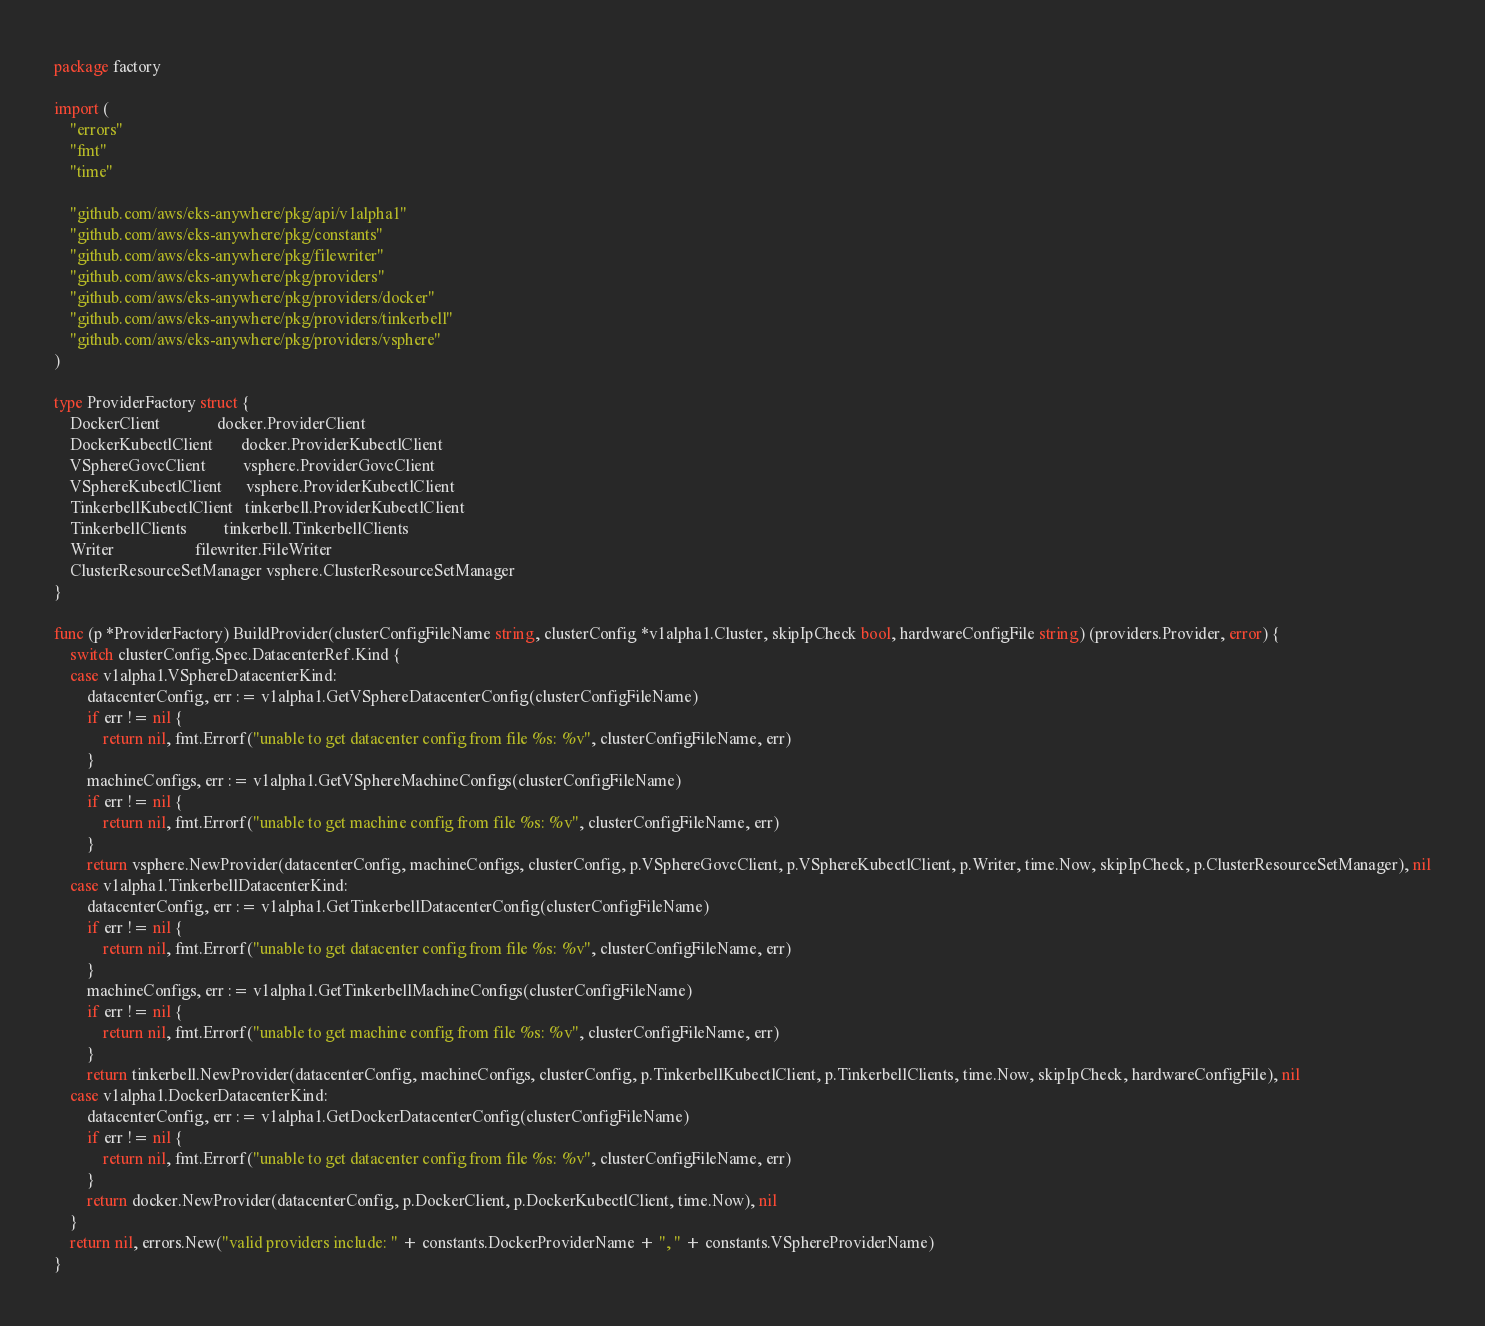<code> <loc_0><loc_0><loc_500><loc_500><_Go_>package factory

import (
	"errors"
	"fmt"
	"time"

	"github.com/aws/eks-anywhere/pkg/api/v1alpha1"
	"github.com/aws/eks-anywhere/pkg/constants"
	"github.com/aws/eks-anywhere/pkg/filewriter"
	"github.com/aws/eks-anywhere/pkg/providers"
	"github.com/aws/eks-anywhere/pkg/providers/docker"
	"github.com/aws/eks-anywhere/pkg/providers/tinkerbell"
	"github.com/aws/eks-anywhere/pkg/providers/vsphere"
)

type ProviderFactory struct {
	DockerClient              docker.ProviderClient
	DockerKubectlClient       docker.ProviderKubectlClient
	VSphereGovcClient         vsphere.ProviderGovcClient
	VSphereKubectlClient      vsphere.ProviderKubectlClient
	TinkerbellKubectlClient   tinkerbell.ProviderKubectlClient
	TinkerbellClients         tinkerbell.TinkerbellClients
	Writer                    filewriter.FileWriter
	ClusterResourceSetManager vsphere.ClusterResourceSetManager
}

func (p *ProviderFactory) BuildProvider(clusterConfigFileName string, clusterConfig *v1alpha1.Cluster, skipIpCheck bool, hardwareConfigFile string) (providers.Provider, error) {
	switch clusterConfig.Spec.DatacenterRef.Kind {
	case v1alpha1.VSphereDatacenterKind:
		datacenterConfig, err := v1alpha1.GetVSphereDatacenterConfig(clusterConfigFileName)
		if err != nil {
			return nil, fmt.Errorf("unable to get datacenter config from file %s: %v", clusterConfigFileName, err)
		}
		machineConfigs, err := v1alpha1.GetVSphereMachineConfigs(clusterConfigFileName)
		if err != nil {
			return nil, fmt.Errorf("unable to get machine config from file %s: %v", clusterConfigFileName, err)
		}
		return vsphere.NewProvider(datacenterConfig, machineConfigs, clusterConfig, p.VSphereGovcClient, p.VSphereKubectlClient, p.Writer, time.Now, skipIpCheck, p.ClusterResourceSetManager), nil
	case v1alpha1.TinkerbellDatacenterKind:
		datacenterConfig, err := v1alpha1.GetTinkerbellDatacenterConfig(clusterConfigFileName)
		if err != nil {
			return nil, fmt.Errorf("unable to get datacenter config from file %s: %v", clusterConfigFileName, err)
		}
		machineConfigs, err := v1alpha1.GetTinkerbellMachineConfigs(clusterConfigFileName)
		if err != nil {
			return nil, fmt.Errorf("unable to get machine config from file %s: %v", clusterConfigFileName, err)
		}
		return tinkerbell.NewProvider(datacenterConfig, machineConfigs, clusterConfig, p.TinkerbellKubectlClient, p.TinkerbellClients, time.Now, skipIpCheck, hardwareConfigFile), nil
	case v1alpha1.DockerDatacenterKind:
		datacenterConfig, err := v1alpha1.GetDockerDatacenterConfig(clusterConfigFileName)
		if err != nil {
			return nil, fmt.Errorf("unable to get datacenter config from file %s: %v", clusterConfigFileName, err)
		}
		return docker.NewProvider(datacenterConfig, p.DockerClient, p.DockerKubectlClient, time.Now), nil
	}
	return nil, errors.New("valid providers include: " + constants.DockerProviderName + ", " + constants.VSphereProviderName)
}
</code> 